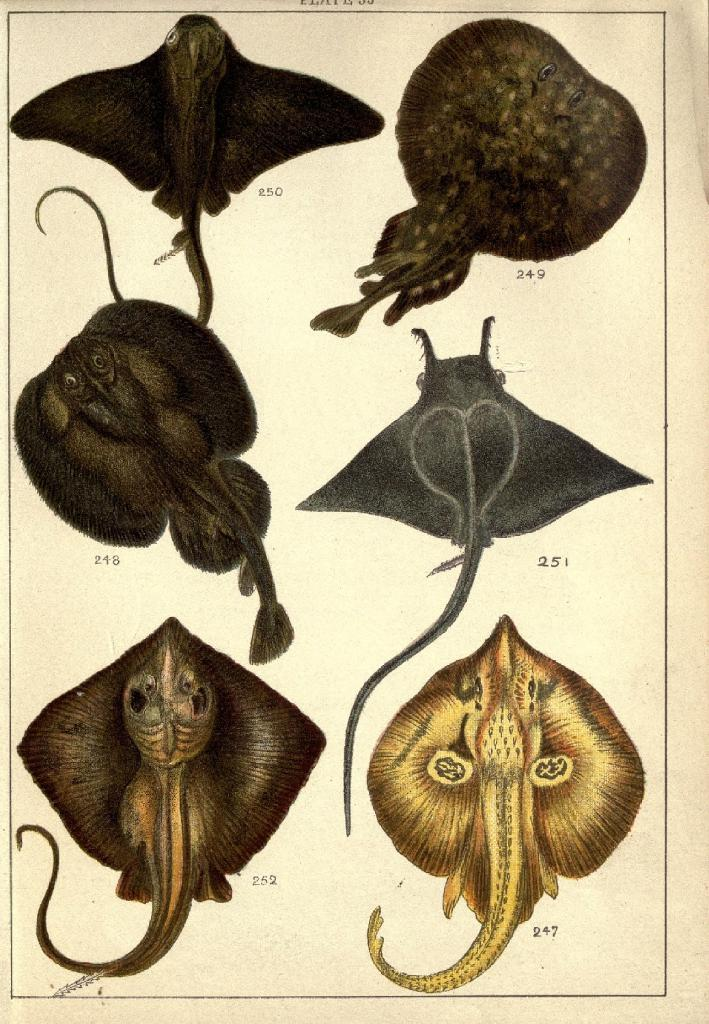What type of animals are depicted on the paper in the image? There are pictures of reptiles on the paper. Can you tell me how many boxes are stacked on top of each other in the image? There is no mention of boxes in the image, as the fact only states that there are pictures of reptiles on the paper. 